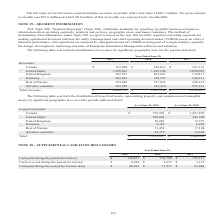According to Opentext Corporation's financial document, What does the table show? distribution of revenues, by significant geographic area, for the periods indicated. The document states: "The following table sets forth the distribution of revenues, by significant geographic area, for the periods indicated:..." Also, What is the full form of CODM? chief operating decision maker. The document states: "nal decisions and how the entity’s management and chief operating decision maker (CODM) assess an entity’s financial performance. Our operations are a..." Also, What are the Fiscal years included in the table? The document contains multiple relevant values: 2019, 2018, 2017. From the document: "2019 2018 2017 Revenues: Canada $ 153,890 $ 149,812 $ 227,115 United States 1,490,863 1,425,244 1,090,049 United K 2019 2018 2017 Revenues: Canada $ 1..." Also, can you calculate: What is the average annual Total revenue? To answer this question, I need to perform calculations using the financial data. The calculation is: (2,868,755+2,815,241+2,291,057)/3, which equals 2658351. This is based on the information: "253,333 Total revenues $ 2,868,755 $ 2,815,241 $ 2,291,057 ,580 322,418 253,333 Total revenues $ 2,868,755 $ 2,815,241 $ 2,291,057 ountries 303,580 322,418 253,333 Total revenues $ 2,868,755 $ 2,815,2..." The key data points involved are: 2,291,057, 2,815,241, 2,868,755. Also, can you calculate: What is the difference between total revenue for fiscal year 2019 and 2018? Based on the calculation: 2,868,755-2,815,241, the result is 53514. This is based on the information: ",580 322,418 253,333 Total revenues $ 2,868,755 $ 2,815,241 $ 2,291,057 ountries 303,580 322,418 253,333 Total revenues $ 2,868,755 $ 2,815,241 $ 2,291,057..." The key data points involved are: 2,815,241, 2,868,755. Also, can you calculate: What is the increase in revenue for Canada from Fiscal year 2018 to 2019? Based on the calculation: 153,890-149,812, the result is 4078. This is based on the information: "2019 2018 2017 Revenues: Canada $ 153,890 $ 149,812 $ 227,115 United States 1,490,863 1,425,244 1,090,049 United Kingdom 182,815 201,821 159,817 German 2019 2018 2017 Revenues: Canada $ 153,890 $ 149,..." The key data points involved are: 149,812, 153,890. 